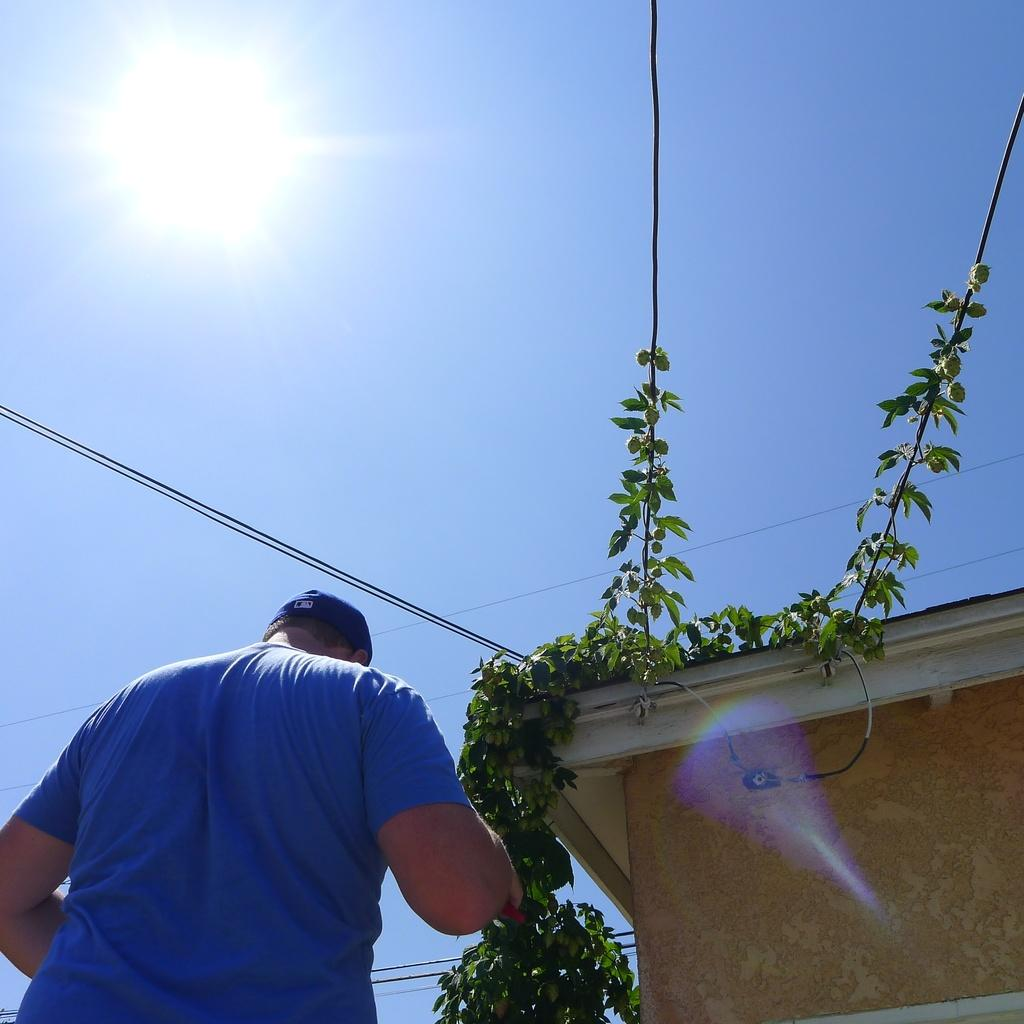What is the person in the image doing? The person is standing beside the building. What can be seen on the building? There are plants on the building. What is the rate of the wax production in the image? There is no mention of wax or its production in the image, so it is not possible to determine the rate of wax production. 